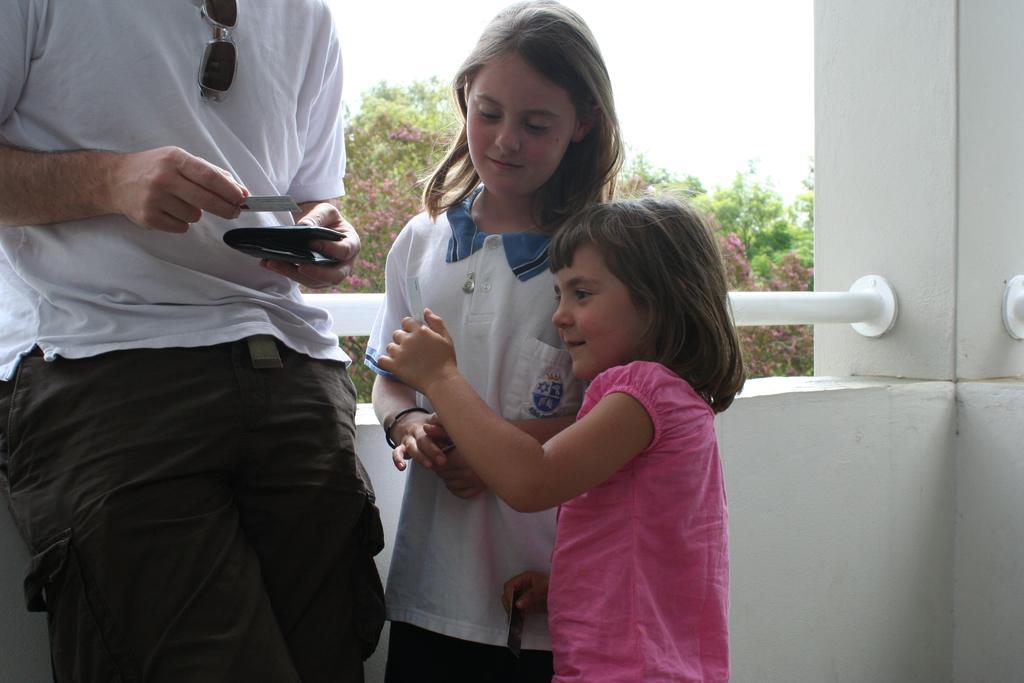How would you summarize this image in a sentence or two? In this image I can see three persons and on the left side person holding a paper and at the top I can see the sky and tree and the person standing in front of the wall and I can see a rod attached to the wall in the middle. 